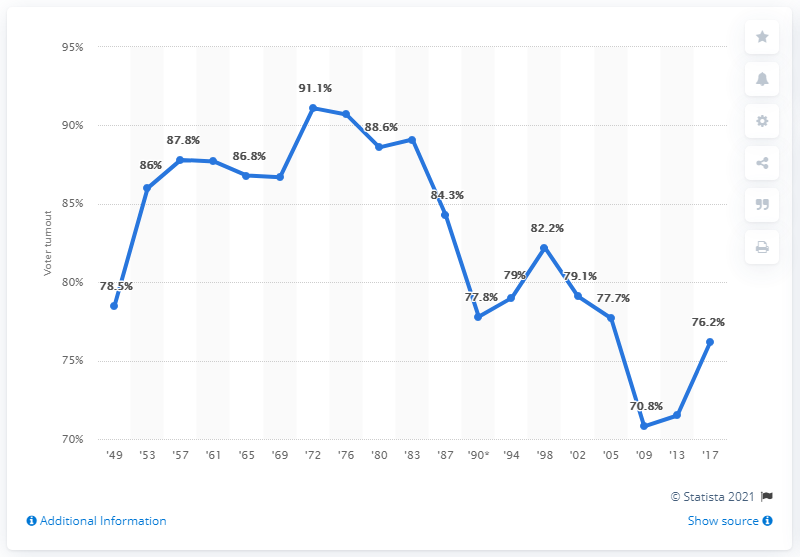Highlight a few significant elements in this photo. The difference between the highest and lowest percentage of voter turnout is 20.3%. The highest voter turnout was 91.1% and the highest percentage was achieved when the highest voter turnout occurred. The most recent election in Germany showed that 76.2% of the voter population participated. 